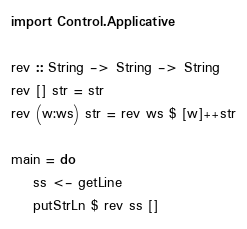<code> <loc_0><loc_0><loc_500><loc_500><_Haskell_>import Control.Applicative

rev :: String -> String -> String
rev [] str = str
rev (w:ws) str = rev ws $ [w]++str

main = do
    ss <- getLine
    putStrLn $ rev ss []</code> 